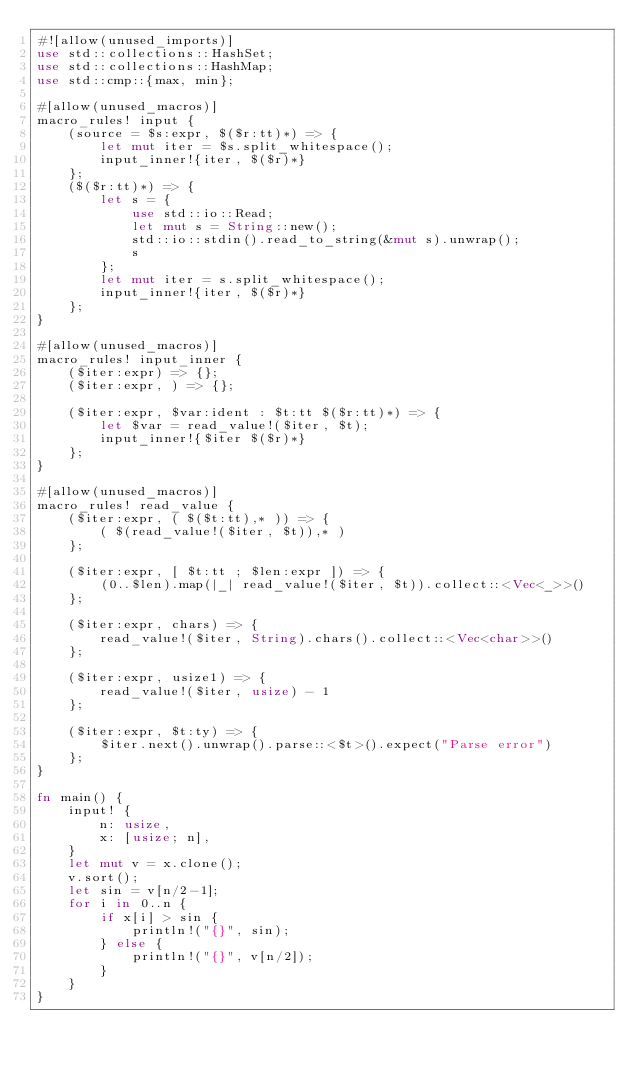Convert code to text. <code><loc_0><loc_0><loc_500><loc_500><_Rust_>#![allow(unused_imports)]
use std::collections::HashSet;
use std::collections::HashMap;
use std::cmp::{max, min};

#[allow(unused_macros)]
macro_rules! input {
    (source = $s:expr, $($r:tt)*) => {
        let mut iter = $s.split_whitespace();
        input_inner!{iter, $($r)*}
    };
    ($($r:tt)*) => {
        let s = {
            use std::io::Read;
            let mut s = String::new();
            std::io::stdin().read_to_string(&mut s).unwrap();
            s
        };
        let mut iter = s.split_whitespace();
        input_inner!{iter, $($r)*}
    };
}

#[allow(unused_macros)]
macro_rules! input_inner {
    ($iter:expr) => {};
    ($iter:expr, ) => {};

    ($iter:expr, $var:ident : $t:tt $($r:tt)*) => {
        let $var = read_value!($iter, $t);
        input_inner!{$iter $($r)*}
    };
}

#[allow(unused_macros)]
macro_rules! read_value {
    ($iter:expr, ( $($t:tt),* )) => {
        ( $(read_value!($iter, $t)),* )
    };

    ($iter:expr, [ $t:tt ; $len:expr ]) => {
        (0..$len).map(|_| read_value!($iter, $t)).collect::<Vec<_>>()
    };

    ($iter:expr, chars) => {
        read_value!($iter, String).chars().collect::<Vec<char>>()
    };

    ($iter:expr, usize1) => {
        read_value!($iter, usize) - 1
    };

    ($iter:expr, $t:ty) => {
        $iter.next().unwrap().parse::<$t>().expect("Parse error")
    };
}

fn main() {
    input! {
        n: usize,
        x: [usize; n],
    }
    let mut v = x.clone();
    v.sort();
    let sin = v[n/2-1];
    for i in 0..n {
        if x[i] > sin {
            println!("{}", sin);
        } else {
            println!("{}", v[n/2]);
        }
    }
}</code> 